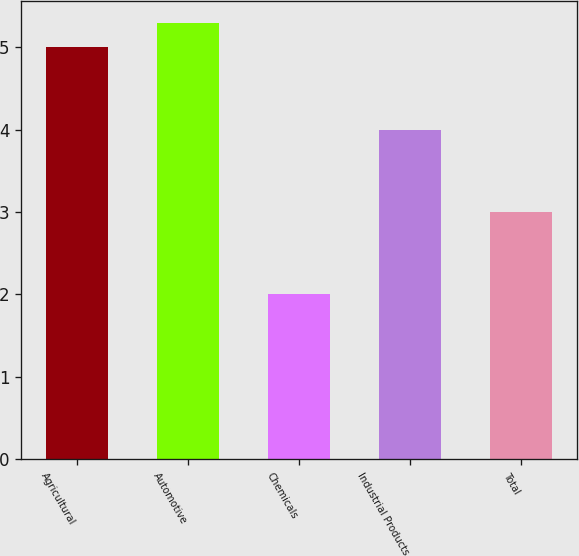<chart> <loc_0><loc_0><loc_500><loc_500><bar_chart><fcel>Agricultural<fcel>Automotive<fcel>Chemicals<fcel>Industrial Products<fcel>Total<nl><fcel>5<fcel>5.3<fcel>2<fcel>4<fcel>3<nl></chart> 